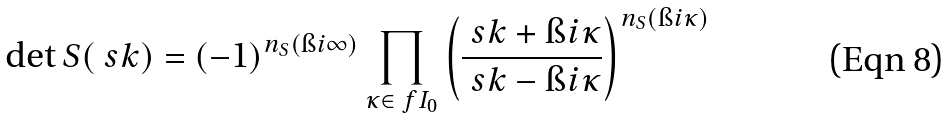Convert formula to latex. <formula><loc_0><loc_0><loc_500><loc_500>\det S ( \ s k ) = ( - 1 ) ^ { n _ { S } ( \i i \infty ) } \prod _ { \kappa \in \ f I _ { 0 } } \left ( \frac { \ s k + \i i \kappa } { \ s k - \i i \kappa } \right ) ^ { n _ { S } ( \i i \kappa ) }</formula> 